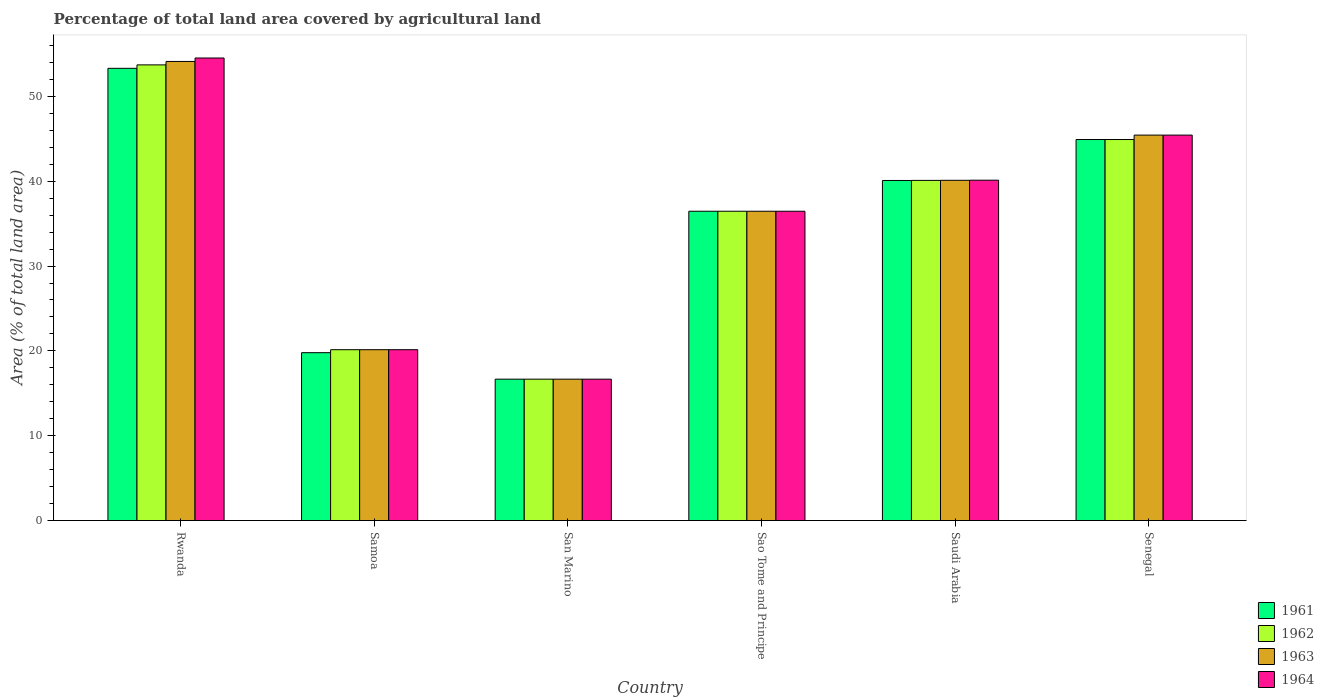How many different coloured bars are there?
Your answer should be very brief. 4. How many bars are there on the 3rd tick from the left?
Ensure brevity in your answer.  4. How many bars are there on the 3rd tick from the right?
Your response must be concise. 4. What is the label of the 4th group of bars from the left?
Give a very brief answer. Sao Tome and Principe. In how many cases, is the number of bars for a given country not equal to the number of legend labels?
Your answer should be compact. 0. What is the percentage of agricultural land in 1961 in Sao Tome and Principe?
Make the answer very short. 36.46. Across all countries, what is the maximum percentage of agricultural land in 1962?
Offer a very short reply. 53.71. Across all countries, what is the minimum percentage of agricultural land in 1963?
Provide a short and direct response. 16.67. In which country was the percentage of agricultural land in 1962 maximum?
Make the answer very short. Rwanda. In which country was the percentage of agricultural land in 1963 minimum?
Provide a succinct answer. San Marino. What is the total percentage of agricultural land in 1964 in the graph?
Your answer should be very brief. 213.34. What is the difference between the percentage of agricultural land in 1961 in Saudi Arabia and that in Senegal?
Your response must be concise. -4.83. What is the difference between the percentage of agricultural land in 1961 in San Marino and the percentage of agricultural land in 1962 in Senegal?
Keep it short and to the point. -28.25. What is the average percentage of agricultural land in 1962 per country?
Give a very brief answer. 35.33. What is the ratio of the percentage of agricultural land in 1962 in Sao Tome and Principe to that in Saudi Arabia?
Provide a succinct answer. 0.91. What is the difference between the highest and the second highest percentage of agricultural land in 1961?
Ensure brevity in your answer.  -4.83. What is the difference between the highest and the lowest percentage of agricultural land in 1962?
Your answer should be very brief. 37.04. Is the sum of the percentage of agricultural land in 1961 in Samoa and Sao Tome and Principe greater than the maximum percentage of agricultural land in 1963 across all countries?
Your answer should be compact. Yes. Is it the case that in every country, the sum of the percentage of agricultural land in 1962 and percentage of agricultural land in 1964 is greater than the sum of percentage of agricultural land in 1963 and percentage of agricultural land in 1961?
Your response must be concise. No. What does the 4th bar from the left in Sao Tome and Principe represents?
Provide a short and direct response. 1964. Are all the bars in the graph horizontal?
Keep it short and to the point. No. How many countries are there in the graph?
Keep it short and to the point. 6. What is the difference between two consecutive major ticks on the Y-axis?
Offer a very short reply. 10. Are the values on the major ticks of Y-axis written in scientific E-notation?
Offer a terse response. No. Does the graph contain grids?
Ensure brevity in your answer.  No. Where does the legend appear in the graph?
Give a very brief answer. Bottom right. How are the legend labels stacked?
Your response must be concise. Vertical. What is the title of the graph?
Your response must be concise. Percentage of total land area covered by agricultural land. Does "1968" appear as one of the legend labels in the graph?
Keep it short and to the point. No. What is the label or title of the X-axis?
Keep it short and to the point. Country. What is the label or title of the Y-axis?
Offer a very short reply. Area (% of total land area). What is the Area (% of total land area) of 1961 in Rwanda?
Your response must be concise. 53.3. What is the Area (% of total land area) of 1962 in Rwanda?
Offer a very short reply. 53.71. What is the Area (% of total land area) of 1963 in Rwanda?
Provide a succinct answer. 54.11. What is the Area (% of total land area) of 1964 in Rwanda?
Your answer should be very brief. 54.52. What is the Area (% of total land area) in 1961 in Samoa?
Your answer should be compact. 19.79. What is the Area (% of total land area) of 1962 in Samoa?
Provide a succinct answer. 20.14. What is the Area (% of total land area) in 1963 in Samoa?
Your response must be concise. 20.14. What is the Area (% of total land area) in 1964 in Samoa?
Provide a short and direct response. 20.14. What is the Area (% of total land area) of 1961 in San Marino?
Give a very brief answer. 16.67. What is the Area (% of total land area) in 1962 in San Marino?
Keep it short and to the point. 16.67. What is the Area (% of total land area) in 1963 in San Marino?
Give a very brief answer. 16.67. What is the Area (% of total land area) in 1964 in San Marino?
Keep it short and to the point. 16.67. What is the Area (% of total land area) in 1961 in Sao Tome and Principe?
Offer a very short reply. 36.46. What is the Area (% of total land area) in 1962 in Sao Tome and Principe?
Give a very brief answer. 36.46. What is the Area (% of total land area) of 1963 in Sao Tome and Principe?
Give a very brief answer. 36.46. What is the Area (% of total land area) in 1964 in Sao Tome and Principe?
Make the answer very short. 36.46. What is the Area (% of total land area) of 1961 in Saudi Arabia?
Ensure brevity in your answer.  40.08. What is the Area (% of total land area) of 1962 in Saudi Arabia?
Make the answer very short. 40.09. What is the Area (% of total land area) of 1963 in Saudi Arabia?
Make the answer very short. 40.1. What is the Area (% of total land area) of 1964 in Saudi Arabia?
Offer a terse response. 40.12. What is the Area (% of total land area) in 1961 in Senegal?
Make the answer very short. 44.91. What is the Area (% of total land area) in 1962 in Senegal?
Offer a terse response. 44.91. What is the Area (% of total land area) in 1963 in Senegal?
Your answer should be compact. 45.43. What is the Area (% of total land area) of 1964 in Senegal?
Your response must be concise. 45.43. Across all countries, what is the maximum Area (% of total land area) in 1961?
Provide a succinct answer. 53.3. Across all countries, what is the maximum Area (% of total land area) in 1962?
Your answer should be compact. 53.71. Across all countries, what is the maximum Area (% of total land area) in 1963?
Give a very brief answer. 54.11. Across all countries, what is the maximum Area (% of total land area) of 1964?
Make the answer very short. 54.52. Across all countries, what is the minimum Area (% of total land area) in 1961?
Offer a terse response. 16.67. Across all countries, what is the minimum Area (% of total land area) in 1962?
Keep it short and to the point. 16.67. Across all countries, what is the minimum Area (% of total land area) of 1963?
Provide a succinct answer. 16.67. Across all countries, what is the minimum Area (% of total land area) in 1964?
Ensure brevity in your answer.  16.67. What is the total Area (% of total land area) of 1961 in the graph?
Your answer should be very brief. 211.21. What is the total Area (% of total land area) in 1962 in the graph?
Make the answer very short. 211.98. What is the total Area (% of total land area) of 1963 in the graph?
Provide a succinct answer. 212.92. What is the total Area (% of total land area) of 1964 in the graph?
Provide a short and direct response. 213.34. What is the difference between the Area (% of total land area) in 1961 in Rwanda and that in Samoa?
Your answer should be compact. 33.52. What is the difference between the Area (% of total land area) in 1962 in Rwanda and that in Samoa?
Keep it short and to the point. 33.57. What is the difference between the Area (% of total land area) of 1963 in Rwanda and that in Samoa?
Your answer should be compact. 33.97. What is the difference between the Area (% of total land area) in 1964 in Rwanda and that in Samoa?
Provide a short and direct response. 34.38. What is the difference between the Area (% of total land area) in 1961 in Rwanda and that in San Marino?
Ensure brevity in your answer.  36.64. What is the difference between the Area (% of total land area) in 1962 in Rwanda and that in San Marino?
Your answer should be compact. 37.04. What is the difference between the Area (% of total land area) of 1963 in Rwanda and that in San Marino?
Give a very brief answer. 37.45. What is the difference between the Area (% of total land area) in 1964 in Rwanda and that in San Marino?
Provide a short and direct response. 37.85. What is the difference between the Area (% of total land area) in 1961 in Rwanda and that in Sao Tome and Principe?
Offer a terse response. 16.85. What is the difference between the Area (% of total land area) in 1962 in Rwanda and that in Sao Tome and Principe?
Your answer should be very brief. 17.25. What is the difference between the Area (% of total land area) in 1963 in Rwanda and that in Sao Tome and Principe?
Keep it short and to the point. 17.66. What is the difference between the Area (% of total land area) of 1964 in Rwanda and that in Sao Tome and Principe?
Offer a terse response. 18.06. What is the difference between the Area (% of total land area) in 1961 in Rwanda and that in Saudi Arabia?
Your answer should be very brief. 13.22. What is the difference between the Area (% of total land area) of 1962 in Rwanda and that in Saudi Arabia?
Your answer should be compact. 13.61. What is the difference between the Area (% of total land area) of 1963 in Rwanda and that in Saudi Arabia?
Your answer should be compact. 14.01. What is the difference between the Area (% of total land area) in 1964 in Rwanda and that in Saudi Arabia?
Give a very brief answer. 14.4. What is the difference between the Area (% of total land area) of 1961 in Rwanda and that in Senegal?
Keep it short and to the point. 8.39. What is the difference between the Area (% of total land area) in 1962 in Rwanda and that in Senegal?
Offer a terse response. 8.8. What is the difference between the Area (% of total land area) of 1963 in Rwanda and that in Senegal?
Give a very brief answer. 8.68. What is the difference between the Area (% of total land area) of 1964 in Rwanda and that in Senegal?
Provide a succinct answer. 9.09. What is the difference between the Area (% of total land area) in 1961 in Samoa and that in San Marino?
Ensure brevity in your answer.  3.12. What is the difference between the Area (% of total land area) in 1962 in Samoa and that in San Marino?
Your answer should be compact. 3.47. What is the difference between the Area (% of total land area) in 1963 in Samoa and that in San Marino?
Provide a succinct answer. 3.47. What is the difference between the Area (% of total land area) of 1964 in Samoa and that in San Marino?
Your response must be concise. 3.47. What is the difference between the Area (% of total land area) of 1961 in Samoa and that in Sao Tome and Principe?
Your answer should be compact. -16.67. What is the difference between the Area (% of total land area) of 1962 in Samoa and that in Sao Tome and Principe?
Your answer should be compact. -16.32. What is the difference between the Area (% of total land area) of 1963 in Samoa and that in Sao Tome and Principe?
Your response must be concise. -16.32. What is the difference between the Area (% of total land area) of 1964 in Samoa and that in Sao Tome and Principe?
Ensure brevity in your answer.  -16.32. What is the difference between the Area (% of total land area) in 1961 in Samoa and that in Saudi Arabia?
Keep it short and to the point. -20.3. What is the difference between the Area (% of total land area) in 1962 in Samoa and that in Saudi Arabia?
Keep it short and to the point. -19.95. What is the difference between the Area (% of total land area) of 1963 in Samoa and that in Saudi Arabia?
Keep it short and to the point. -19.96. What is the difference between the Area (% of total land area) of 1964 in Samoa and that in Saudi Arabia?
Your answer should be very brief. -19.98. What is the difference between the Area (% of total land area) of 1961 in Samoa and that in Senegal?
Ensure brevity in your answer.  -25.12. What is the difference between the Area (% of total land area) of 1962 in Samoa and that in Senegal?
Your answer should be very brief. -24.77. What is the difference between the Area (% of total land area) in 1963 in Samoa and that in Senegal?
Provide a short and direct response. -25.29. What is the difference between the Area (% of total land area) in 1964 in Samoa and that in Senegal?
Offer a terse response. -25.29. What is the difference between the Area (% of total land area) of 1961 in San Marino and that in Sao Tome and Principe?
Your answer should be compact. -19.79. What is the difference between the Area (% of total land area) in 1962 in San Marino and that in Sao Tome and Principe?
Keep it short and to the point. -19.79. What is the difference between the Area (% of total land area) of 1963 in San Marino and that in Sao Tome and Principe?
Your answer should be compact. -19.79. What is the difference between the Area (% of total land area) in 1964 in San Marino and that in Sao Tome and Principe?
Your response must be concise. -19.79. What is the difference between the Area (% of total land area) of 1961 in San Marino and that in Saudi Arabia?
Your response must be concise. -23.42. What is the difference between the Area (% of total land area) in 1962 in San Marino and that in Saudi Arabia?
Your response must be concise. -23.43. What is the difference between the Area (% of total land area) of 1963 in San Marino and that in Saudi Arabia?
Your answer should be very brief. -23.44. What is the difference between the Area (% of total land area) of 1964 in San Marino and that in Saudi Arabia?
Give a very brief answer. -23.45. What is the difference between the Area (% of total land area) in 1961 in San Marino and that in Senegal?
Provide a succinct answer. -28.25. What is the difference between the Area (% of total land area) in 1962 in San Marino and that in Senegal?
Offer a terse response. -28.25. What is the difference between the Area (% of total land area) of 1963 in San Marino and that in Senegal?
Provide a short and direct response. -28.77. What is the difference between the Area (% of total land area) in 1964 in San Marino and that in Senegal?
Provide a succinct answer. -28.77. What is the difference between the Area (% of total land area) in 1961 in Sao Tome and Principe and that in Saudi Arabia?
Ensure brevity in your answer.  -3.63. What is the difference between the Area (% of total land area) of 1962 in Sao Tome and Principe and that in Saudi Arabia?
Your answer should be compact. -3.64. What is the difference between the Area (% of total land area) in 1963 in Sao Tome and Principe and that in Saudi Arabia?
Provide a short and direct response. -3.65. What is the difference between the Area (% of total land area) in 1964 in Sao Tome and Principe and that in Saudi Arabia?
Provide a short and direct response. -3.66. What is the difference between the Area (% of total land area) in 1961 in Sao Tome and Principe and that in Senegal?
Ensure brevity in your answer.  -8.45. What is the difference between the Area (% of total land area) of 1962 in Sao Tome and Principe and that in Senegal?
Offer a terse response. -8.45. What is the difference between the Area (% of total land area) in 1963 in Sao Tome and Principe and that in Senegal?
Provide a succinct answer. -8.97. What is the difference between the Area (% of total land area) in 1964 in Sao Tome and Principe and that in Senegal?
Make the answer very short. -8.97. What is the difference between the Area (% of total land area) in 1961 in Saudi Arabia and that in Senegal?
Provide a succinct answer. -4.83. What is the difference between the Area (% of total land area) in 1962 in Saudi Arabia and that in Senegal?
Make the answer very short. -4.82. What is the difference between the Area (% of total land area) in 1963 in Saudi Arabia and that in Senegal?
Ensure brevity in your answer.  -5.33. What is the difference between the Area (% of total land area) in 1964 in Saudi Arabia and that in Senegal?
Your response must be concise. -5.31. What is the difference between the Area (% of total land area) of 1961 in Rwanda and the Area (% of total land area) of 1962 in Samoa?
Offer a terse response. 33.16. What is the difference between the Area (% of total land area) of 1961 in Rwanda and the Area (% of total land area) of 1963 in Samoa?
Keep it short and to the point. 33.16. What is the difference between the Area (% of total land area) of 1961 in Rwanda and the Area (% of total land area) of 1964 in Samoa?
Your response must be concise. 33.16. What is the difference between the Area (% of total land area) of 1962 in Rwanda and the Area (% of total land area) of 1963 in Samoa?
Ensure brevity in your answer.  33.57. What is the difference between the Area (% of total land area) of 1962 in Rwanda and the Area (% of total land area) of 1964 in Samoa?
Provide a short and direct response. 33.57. What is the difference between the Area (% of total land area) of 1963 in Rwanda and the Area (% of total land area) of 1964 in Samoa?
Provide a short and direct response. 33.97. What is the difference between the Area (% of total land area) in 1961 in Rwanda and the Area (% of total land area) in 1962 in San Marino?
Your response must be concise. 36.64. What is the difference between the Area (% of total land area) of 1961 in Rwanda and the Area (% of total land area) of 1963 in San Marino?
Your answer should be very brief. 36.64. What is the difference between the Area (% of total land area) of 1961 in Rwanda and the Area (% of total land area) of 1964 in San Marino?
Give a very brief answer. 36.64. What is the difference between the Area (% of total land area) of 1962 in Rwanda and the Area (% of total land area) of 1963 in San Marino?
Your answer should be very brief. 37.04. What is the difference between the Area (% of total land area) in 1962 in Rwanda and the Area (% of total land area) in 1964 in San Marino?
Give a very brief answer. 37.04. What is the difference between the Area (% of total land area) in 1963 in Rwanda and the Area (% of total land area) in 1964 in San Marino?
Keep it short and to the point. 37.45. What is the difference between the Area (% of total land area) in 1961 in Rwanda and the Area (% of total land area) in 1962 in Sao Tome and Principe?
Give a very brief answer. 16.85. What is the difference between the Area (% of total land area) of 1961 in Rwanda and the Area (% of total land area) of 1963 in Sao Tome and Principe?
Provide a short and direct response. 16.85. What is the difference between the Area (% of total land area) of 1961 in Rwanda and the Area (% of total land area) of 1964 in Sao Tome and Principe?
Your answer should be very brief. 16.85. What is the difference between the Area (% of total land area) in 1962 in Rwanda and the Area (% of total land area) in 1963 in Sao Tome and Principe?
Make the answer very short. 17.25. What is the difference between the Area (% of total land area) in 1962 in Rwanda and the Area (% of total land area) in 1964 in Sao Tome and Principe?
Keep it short and to the point. 17.25. What is the difference between the Area (% of total land area) in 1963 in Rwanda and the Area (% of total land area) in 1964 in Sao Tome and Principe?
Your response must be concise. 17.66. What is the difference between the Area (% of total land area) of 1961 in Rwanda and the Area (% of total land area) of 1962 in Saudi Arabia?
Provide a short and direct response. 13.21. What is the difference between the Area (% of total land area) in 1961 in Rwanda and the Area (% of total land area) in 1963 in Saudi Arabia?
Keep it short and to the point. 13.2. What is the difference between the Area (% of total land area) of 1961 in Rwanda and the Area (% of total land area) of 1964 in Saudi Arabia?
Ensure brevity in your answer.  13.19. What is the difference between the Area (% of total land area) of 1962 in Rwanda and the Area (% of total land area) of 1963 in Saudi Arabia?
Keep it short and to the point. 13.6. What is the difference between the Area (% of total land area) in 1962 in Rwanda and the Area (% of total land area) in 1964 in Saudi Arabia?
Provide a succinct answer. 13.59. What is the difference between the Area (% of total land area) in 1963 in Rwanda and the Area (% of total land area) in 1964 in Saudi Arabia?
Make the answer very short. 14. What is the difference between the Area (% of total land area) in 1961 in Rwanda and the Area (% of total land area) in 1962 in Senegal?
Make the answer very short. 8.39. What is the difference between the Area (% of total land area) of 1961 in Rwanda and the Area (% of total land area) of 1963 in Senegal?
Your answer should be compact. 7.87. What is the difference between the Area (% of total land area) of 1961 in Rwanda and the Area (% of total land area) of 1964 in Senegal?
Provide a succinct answer. 7.87. What is the difference between the Area (% of total land area) of 1962 in Rwanda and the Area (% of total land area) of 1963 in Senegal?
Your response must be concise. 8.28. What is the difference between the Area (% of total land area) in 1962 in Rwanda and the Area (% of total land area) in 1964 in Senegal?
Make the answer very short. 8.28. What is the difference between the Area (% of total land area) of 1963 in Rwanda and the Area (% of total land area) of 1964 in Senegal?
Your answer should be compact. 8.68. What is the difference between the Area (% of total land area) in 1961 in Samoa and the Area (% of total land area) in 1962 in San Marino?
Your answer should be very brief. 3.12. What is the difference between the Area (% of total land area) of 1961 in Samoa and the Area (% of total land area) of 1963 in San Marino?
Keep it short and to the point. 3.12. What is the difference between the Area (% of total land area) of 1961 in Samoa and the Area (% of total land area) of 1964 in San Marino?
Your answer should be very brief. 3.12. What is the difference between the Area (% of total land area) of 1962 in Samoa and the Area (% of total land area) of 1963 in San Marino?
Offer a very short reply. 3.47. What is the difference between the Area (% of total land area) of 1962 in Samoa and the Area (% of total land area) of 1964 in San Marino?
Provide a short and direct response. 3.47. What is the difference between the Area (% of total land area) in 1963 in Samoa and the Area (% of total land area) in 1964 in San Marino?
Provide a succinct answer. 3.47. What is the difference between the Area (% of total land area) of 1961 in Samoa and the Area (% of total land area) of 1962 in Sao Tome and Principe?
Your answer should be very brief. -16.67. What is the difference between the Area (% of total land area) of 1961 in Samoa and the Area (% of total land area) of 1963 in Sao Tome and Principe?
Offer a very short reply. -16.67. What is the difference between the Area (% of total land area) in 1961 in Samoa and the Area (% of total land area) in 1964 in Sao Tome and Principe?
Provide a short and direct response. -16.67. What is the difference between the Area (% of total land area) in 1962 in Samoa and the Area (% of total land area) in 1963 in Sao Tome and Principe?
Provide a succinct answer. -16.32. What is the difference between the Area (% of total land area) of 1962 in Samoa and the Area (% of total land area) of 1964 in Sao Tome and Principe?
Provide a succinct answer. -16.32. What is the difference between the Area (% of total land area) in 1963 in Samoa and the Area (% of total land area) in 1964 in Sao Tome and Principe?
Provide a short and direct response. -16.32. What is the difference between the Area (% of total land area) of 1961 in Samoa and the Area (% of total land area) of 1962 in Saudi Arabia?
Your answer should be very brief. -20.31. What is the difference between the Area (% of total land area) in 1961 in Samoa and the Area (% of total land area) in 1963 in Saudi Arabia?
Your answer should be very brief. -20.32. What is the difference between the Area (% of total land area) in 1961 in Samoa and the Area (% of total land area) in 1964 in Saudi Arabia?
Make the answer very short. -20.33. What is the difference between the Area (% of total land area) in 1962 in Samoa and the Area (% of total land area) in 1963 in Saudi Arabia?
Provide a short and direct response. -19.96. What is the difference between the Area (% of total land area) of 1962 in Samoa and the Area (% of total land area) of 1964 in Saudi Arabia?
Offer a very short reply. -19.98. What is the difference between the Area (% of total land area) in 1963 in Samoa and the Area (% of total land area) in 1964 in Saudi Arabia?
Ensure brevity in your answer.  -19.98. What is the difference between the Area (% of total land area) of 1961 in Samoa and the Area (% of total land area) of 1962 in Senegal?
Give a very brief answer. -25.12. What is the difference between the Area (% of total land area) in 1961 in Samoa and the Area (% of total land area) in 1963 in Senegal?
Your answer should be compact. -25.64. What is the difference between the Area (% of total land area) in 1961 in Samoa and the Area (% of total land area) in 1964 in Senegal?
Offer a very short reply. -25.64. What is the difference between the Area (% of total land area) of 1962 in Samoa and the Area (% of total land area) of 1963 in Senegal?
Your answer should be very brief. -25.29. What is the difference between the Area (% of total land area) in 1962 in Samoa and the Area (% of total land area) in 1964 in Senegal?
Keep it short and to the point. -25.29. What is the difference between the Area (% of total land area) of 1963 in Samoa and the Area (% of total land area) of 1964 in Senegal?
Provide a succinct answer. -25.29. What is the difference between the Area (% of total land area) of 1961 in San Marino and the Area (% of total land area) of 1962 in Sao Tome and Principe?
Offer a terse response. -19.79. What is the difference between the Area (% of total land area) in 1961 in San Marino and the Area (% of total land area) in 1963 in Sao Tome and Principe?
Your answer should be very brief. -19.79. What is the difference between the Area (% of total land area) in 1961 in San Marino and the Area (% of total land area) in 1964 in Sao Tome and Principe?
Give a very brief answer. -19.79. What is the difference between the Area (% of total land area) in 1962 in San Marino and the Area (% of total land area) in 1963 in Sao Tome and Principe?
Your answer should be very brief. -19.79. What is the difference between the Area (% of total land area) of 1962 in San Marino and the Area (% of total land area) of 1964 in Sao Tome and Principe?
Your answer should be very brief. -19.79. What is the difference between the Area (% of total land area) of 1963 in San Marino and the Area (% of total land area) of 1964 in Sao Tome and Principe?
Give a very brief answer. -19.79. What is the difference between the Area (% of total land area) of 1961 in San Marino and the Area (% of total land area) of 1962 in Saudi Arabia?
Offer a very short reply. -23.43. What is the difference between the Area (% of total land area) in 1961 in San Marino and the Area (% of total land area) in 1963 in Saudi Arabia?
Provide a succinct answer. -23.44. What is the difference between the Area (% of total land area) of 1961 in San Marino and the Area (% of total land area) of 1964 in Saudi Arabia?
Give a very brief answer. -23.45. What is the difference between the Area (% of total land area) of 1962 in San Marino and the Area (% of total land area) of 1963 in Saudi Arabia?
Offer a terse response. -23.44. What is the difference between the Area (% of total land area) in 1962 in San Marino and the Area (% of total land area) in 1964 in Saudi Arabia?
Your response must be concise. -23.45. What is the difference between the Area (% of total land area) in 1963 in San Marino and the Area (% of total land area) in 1964 in Saudi Arabia?
Your answer should be compact. -23.45. What is the difference between the Area (% of total land area) of 1961 in San Marino and the Area (% of total land area) of 1962 in Senegal?
Keep it short and to the point. -28.25. What is the difference between the Area (% of total land area) in 1961 in San Marino and the Area (% of total land area) in 1963 in Senegal?
Your response must be concise. -28.77. What is the difference between the Area (% of total land area) of 1961 in San Marino and the Area (% of total land area) of 1964 in Senegal?
Keep it short and to the point. -28.77. What is the difference between the Area (% of total land area) in 1962 in San Marino and the Area (% of total land area) in 1963 in Senegal?
Your response must be concise. -28.77. What is the difference between the Area (% of total land area) of 1962 in San Marino and the Area (% of total land area) of 1964 in Senegal?
Keep it short and to the point. -28.77. What is the difference between the Area (% of total land area) of 1963 in San Marino and the Area (% of total land area) of 1964 in Senegal?
Provide a succinct answer. -28.77. What is the difference between the Area (% of total land area) in 1961 in Sao Tome and Principe and the Area (% of total land area) in 1962 in Saudi Arabia?
Provide a succinct answer. -3.64. What is the difference between the Area (% of total land area) in 1961 in Sao Tome and Principe and the Area (% of total land area) in 1963 in Saudi Arabia?
Provide a succinct answer. -3.65. What is the difference between the Area (% of total land area) of 1961 in Sao Tome and Principe and the Area (% of total land area) of 1964 in Saudi Arabia?
Your response must be concise. -3.66. What is the difference between the Area (% of total land area) of 1962 in Sao Tome and Principe and the Area (% of total land area) of 1963 in Saudi Arabia?
Provide a succinct answer. -3.65. What is the difference between the Area (% of total land area) in 1962 in Sao Tome and Principe and the Area (% of total land area) in 1964 in Saudi Arabia?
Your response must be concise. -3.66. What is the difference between the Area (% of total land area) in 1963 in Sao Tome and Principe and the Area (% of total land area) in 1964 in Saudi Arabia?
Provide a succinct answer. -3.66. What is the difference between the Area (% of total land area) of 1961 in Sao Tome and Principe and the Area (% of total land area) of 1962 in Senegal?
Keep it short and to the point. -8.45. What is the difference between the Area (% of total land area) in 1961 in Sao Tome and Principe and the Area (% of total land area) in 1963 in Senegal?
Provide a short and direct response. -8.97. What is the difference between the Area (% of total land area) of 1961 in Sao Tome and Principe and the Area (% of total land area) of 1964 in Senegal?
Your response must be concise. -8.97. What is the difference between the Area (% of total land area) of 1962 in Sao Tome and Principe and the Area (% of total land area) of 1963 in Senegal?
Make the answer very short. -8.97. What is the difference between the Area (% of total land area) of 1962 in Sao Tome and Principe and the Area (% of total land area) of 1964 in Senegal?
Provide a short and direct response. -8.97. What is the difference between the Area (% of total land area) in 1963 in Sao Tome and Principe and the Area (% of total land area) in 1964 in Senegal?
Your response must be concise. -8.97. What is the difference between the Area (% of total land area) in 1961 in Saudi Arabia and the Area (% of total land area) in 1962 in Senegal?
Provide a succinct answer. -4.83. What is the difference between the Area (% of total land area) of 1961 in Saudi Arabia and the Area (% of total land area) of 1963 in Senegal?
Provide a short and direct response. -5.35. What is the difference between the Area (% of total land area) of 1961 in Saudi Arabia and the Area (% of total land area) of 1964 in Senegal?
Provide a short and direct response. -5.35. What is the difference between the Area (% of total land area) of 1962 in Saudi Arabia and the Area (% of total land area) of 1963 in Senegal?
Your response must be concise. -5.34. What is the difference between the Area (% of total land area) in 1962 in Saudi Arabia and the Area (% of total land area) in 1964 in Senegal?
Your answer should be compact. -5.34. What is the difference between the Area (% of total land area) of 1963 in Saudi Arabia and the Area (% of total land area) of 1964 in Senegal?
Give a very brief answer. -5.33. What is the average Area (% of total land area) in 1961 per country?
Your answer should be compact. 35.2. What is the average Area (% of total land area) in 1962 per country?
Give a very brief answer. 35.33. What is the average Area (% of total land area) in 1963 per country?
Your response must be concise. 35.49. What is the average Area (% of total land area) of 1964 per country?
Give a very brief answer. 35.56. What is the difference between the Area (% of total land area) in 1961 and Area (% of total land area) in 1962 in Rwanda?
Offer a terse response. -0.41. What is the difference between the Area (% of total land area) in 1961 and Area (% of total land area) in 1963 in Rwanda?
Provide a succinct answer. -0.81. What is the difference between the Area (% of total land area) in 1961 and Area (% of total land area) in 1964 in Rwanda?
Ensure brevity in your answer.  -1.22. What is the difference between the Area (% of total land area) in 1962 and Area (% of total land area) in 1963 in Rwanda?
Your answer should be compact. -0.41. What is the difference between the Area (% of total land area) in 1962 and Area (% of total land area) in 1964 in Rwanda?
Make the answer very short. -0.81. What is the difference between the Area (% of total land area) of 1963 and Area (% of total land area) of 1964 in Rwanda?
Offer a very short reply. -0.41. What is the difference between the Area (% of total land area) in 1961 and Area (% of total land area) in 1962 in Samoa?
Make the answer very short. -0.35. What is the difference between the Area (% of total land area) of 1961 and Area (% of total land area) of 1963 in Samoa?
Offer a terse response. -0.35. What is the difference between the Area (% of total land area) of 1961 and Area (% of total land area) of 1964 in Samoa?
Ensure brevity in your answer.  -0.35. What is the difference between the Area (% of total land area) of 1963 and Area (% of total land area) of 1964 in Samoa?
Your response must be concise. 0. What is the difference between the Area (% of total land area) in 1961 and Area (% of total land area) in 1962 in San Marino?
Your answer should be very brief. 0. What is the difference between the Area (% of total land area) in 1961 and Area (% of total land area) in 1963 in San Marino?
Keep it short and to the point. 0. What is the difference between the Area (% of total land area) in 1961 and Area (% of total land area) in 1964 in San Marino?
Provide a succinct answer. 0. What is the difference between the Area (% of total land area) in 1961 and Area (% of total land area) in 1963 in Sao Tome and Principe?
Keep it short and to the point. 0. What is the difference between the Area (% of total land area) of 1961 and Area (% of total land area) of 1964 in Sao Tome and Principe?
Keep it short and to the point. 0. What is the difference between the Area (% of total land area) of 1962 and Area (% of total land area) of 1963 in Sao Tome and Principe?
Your answer should be very brief. 0. What is the difference between the Area (% of total land area) of 1961 and Area (% of total land area) of 1962 in Saudi Arabia?
Provide a short and direct response. -0.01. What is the difference between the Area (% of total land area) of 1961 and Area (% of total land area) of 1963 in Saudi Arabia?
Your response must be concise. -0.02. What is the difference between the Area (% of total land area) of 1961 and Area (% of total land area) of 1964 in Saudi Arabia?
Ensure brevity in your answer.  -0.03. What is the difference between the Area (% of total land area) of 1962 and Area (% of total land area) of 1963 in Saudi Arabia?
Your response must be concise. -0.01. What is the difference between the Area (% of total land area) in 1962 and Area (% of total land area) in 1964 in Saudi Arabia?
Ensure brevity in your answer.  -0.02. What is the difference between the Area (% of total land area) of 1963 and Area (% of total land area) of 1964 in Saudi Arabia?
Your response must be concise. -0.01. What is the difference between the Area (% of total land area) in 1961 and Area (% of total land area) in 1963 in Senegal?
Make the answer very short. -0.52. What is the difference between the Area (% of total land area) of 1961 and Area (% of total land area) of 1964 in Senegal?
Ensure brevity in your answer.  -0.52. What is the difference between the Area (% of total land area) in 1962 and Area (% of total land area) in 1963 in Senegal?
Your answer should be compact. -0.52. What is the difference between the Area (% of total land area) of 1962 and Area (% of total land area) of 1964 in Senegal?
Ensure brevity in your answer.  -0.52. What is the difference between the Area (% of total land area) in 1963 and Area (% of total land area) in 1964 in Senegal?
Your answer should be very brief. 0. What is the ratio of the Area (% of total land area) of 1961 in Rwanda to that in Samoa?
Your answer should be compact. 2.69. What is the ratio of the Area (% of total land area) of 1962 in Rwanda to that in Samoa?
Your answer should be compact. 2.67. What is the ratio of the Area (% of total land area) in 1963 in Rwanda to that in Samoa?
Provide a succinct answer. 2.69. What is the ratio of the Area (% of total land area) in 1964 in Rwanda to that in Samoa?
Offer a very short reply. 2.71. What is the ratio of the Area (% of total land area) of 1961 in Rwanda to that in San Marino?
Your answer should be very brief. 3.2. What is the ratio of the Area (% of total land area) in 1962 in Rwanda to that in San Marino?
Your answer should be compact. 3.22. What is the ratio of the Area (% of total land area) in 1963 in Rwanda to that in San Marino?
Provide a succinct answer. 3.25. What is the ratio of the Area (% of total land area) in 1964 in Rwanda to that in San Marino?
Provide a short and direct response. 3.27. What is the ratio of the Area (% of total land area) in 1961 in Rwanda to that in Sao Tome and Principe?
Offer a very short reply. 1.46. What is the ratio of the Area (% of total land area) of 1962 in Rwanda to that in Sao Tome and Principe?
Your response must be concise. 1.47. What is the ratio of the Area (% of total land area) in 1963 in Rwanda to that in Sao Tome and Principe?
Your answer should be compact. 1.48. What is the ratio of the Area (% of total land area) of 1964 in Rwanda to that in Sao Tome and Principe?
Provide a succinct answer. 1.5. What is the ratio of the Area (% of total land area) of 1961 in Rwanda to that in Saudi Arabia?
Offer a very short reply. 1.33. What is the ratio of the Area (% of total land area) in 1962 in Rwanda to that in Saudi Arabia?
Keep it short and to the point. 1.34. What is the ratio of the Area (% of total land area) in 1963 in Rwanda to that in Saudi Arabia?
Provide a short and direct response. 1.35. What is the ratio of the Area (% of total land area) in 1964 in Rwanda to that in Saudi Arabia?
Give a very brief answer. 1.36. What is the ratio of the Area (% of total land area) in 1961 in Rwanda to that in Senegal?
Your response must be concise. 1.19. What is the ratio of the Area (% of total land area) in 1962 in Rwanda to that in Senegal?
Your answer should be compact. 1.2. What is the ratio of the Area (% of total land area) of 1963 in Rwanda to that in Senegal?
Keep it short and to the point. 1.19. What is the ratio of the Area (% of total land area) in 1964 in Rwanda to that in Senegal?
Make the answer very short. 1.2. What is the ratio of the Area (% of total land area) in 1961 in Samoa to that in San Marino?
Give a very brief answer. 1.19. What is the ratio of the Area (% of total land area) of 1962 in Samoa to that in San Marino?
Give a very brief answer. 1.21. What is the ratio of the Area (% of total land area) of 1963 in Samoa to that in San Marino?
Provide a succinct answer. 1.21. What is the ratio of the Area (% of total land area) in 1964 in Samoa to that in San Marino?
Ensure brevity in your answer.  1.21. What is the ratio of the Area (% of total land area) of 1961 in Samoa to that in Sao Tome and Principe?
Your answer should be very brief. 0.54. What is the ratio of the Area (% of total land area) in 1962 in Samoa to that in Sao Tome and Principe?
Give a very brief answer. 0.55. What is the ratio of the Area (% of total land area) in 1963 in Samoa to that in Sao Tome and Principe?
Provide a succinct answer. 0.55. What is the ratio of the Area (% of total land area) in 1964 in Samoa to that in Sao Tome and Principe?
Your answer should be very brief. 0.55. What is the ratio of the Area (% of total land area) in 1961 in Samoa to that in Saudi Arabia?
Your response must be concise. 0.49. What is the ratio of the Area (% of total land area) of 1962 in Samoa to that in Saudi Arabia?
Ensure brevity in your answer.  0.5. What is the ratio of the Area (% of total land area) in 1963 in Samoa to that in Saudi Arabia?
Keep it short and to the point. 0.5. What is the ratio of the Area (% of total land area) of 1964 in Samoa to that in Saudi Arabia?
Keep it short and to the point. 0.5. What is the ratio of the Area (% of total land area) in 1961 in Samoa to that in Senegal?
Your answer should be very brief. 0.44. What is the ratio of the Area (% of total land area) of 1962 in Samoa to that in Senegal?
Offer a very short reply. 0.45. What is the ratio of the Area (% of total land area) of 1963 in Samoa to that in Senegal?
Offer a very short reply. 0.44. What is the ratio of the Area (% of total land area) of 1964 in Samoa to that in Senegal?
Your answer should be compact. 0.44. What is the ratio of the Area (% of total land area) of 1961 in San Marino to that in Sao Tome and Principe?
Offer a very short reply. 0.46. What is the ratio of the Area (% of total land area) of 1962 in San Marino to that in Sao Tome and Principe?
Keep it short and to the point. 0.46. What is the ratio of the Area (% of total land area) in 1963 in San Marino to that in Sao Tome and Principe?
Give a very brief answer. 0.46. What is the ratio of the Area (% of total land area) of 1964 in San Marino to that in Sao Tome and Principe?
Your answer should be very brief. 0.46. What is the ratio of the Area (% of total land area) of 1961 in San Marino to that in Saudi Arabia?
Your response must be concise. 0.42. What is the ratio of the Area (% of total land area) in 1962 in San Marino to that in Saudi Arabia?
Your answer should be very brief. 0.42. What is the ratio of the Area (% of total land area) of 1963 in San Marino to that in Saudi Arabia?
Give a very brief answer. 0.42. What is the ratio of the Area (% of total land area) of 1964 in San Marino to that in Saudi Arabia?
Offer a very short reply. 0.42. What is the ratio of the Area (% of total land area) of 1961 in San Marino to that in Senegal?
Ensure brevity in your answer.  0.37. What is the ratio of the Area (% of total land area) in 1962 in San Marino to that in Senegal?
Provide a short and direct response. 0.37. What is the ratio of the Area (% of total land area) of 1963 in San Marino to that in Senegal?
Your response must be concise. 0.37. What is the ratio of the Area (% of total land area) of 1964 in San Marino to that in Senegal?
Your answer should be compact. 0.37. What is the ratio of the Area (% of total land area) in 1961 in Sao Tome and Principe to that in Saudi Arabia?
Your answer should be compact. 0.91. What is the ratio of the Area (% of total land area) of 1962 in Sao Tome and Principe to that in Saudi Arabia?
Offer a terse response. 0.91. What is the ratio of the Area (% of total land area) of 1964 in Sao Tome and Principe to that in Saudi Arabia?
Your answer should be compact. 0.91. What is the ratio of the Area (% of total land area) in 1961 in Sao Tome and Principe to that in Senegal?
Your answer should be very brief. 0.81. What is the ratio of the Area (% of total land area) in 1962 in Sao Tome and Principe to that in Senegal?
Your response must be concise. 0.81. What is the ratio of the Area (% of total land area) of 1963 in Sao Tome and Principe to that in Senegal?
Your response must be concise. 0.8. What is the ratio of the Area (% of total land area) in 1964 in Sao Tome and Principe to that in Senegal?
Offer a very short reply. 0.8. What is the ratio of the Area (% of total land area) in 1961 in Saudi Arabia to that in Senegal?
Your answer should be compact. 0.89. What is the ratio of the Area (% of total land area) of 1962 in Saudi Arabia to that in Senegal?
Ensure brevity in your answer.  0.89. What is the ratio of the Area (% of total land area) in 1963 in Saudi Arabia to that in Senegal?
Your response must be concise. 0.88. What is the ratio of the Area (% of total land area) in 1964 in Saudi Arabia to that in Senegal?
Offer a very short reply. 0.88. What is the difference between the highest and the second highest Area (% of total land area) of 1961?
Provide a succinct answer. 8.39. What is the difference between the highest and the second highest Area (% of total land area) of 1962?
Provide a short and direct response. 8.8. What is the difference between the highest and the second highest Area (% of total land area) in 1963?
Your answer should be compact. 8.68. What is the difference between the highest and the second highest Area (% of total land area) in 1964?
Offer a very short reply. 9.09. What is the difference between the highest and the lowest Area (% of total land area) of 1961?
Keep it short and to the point. 36.64. What is the difference between the highest and the lowest Area (% of total land area) of 1962?
Make the answer very short. 37.04. What is the difference between the highest and the lowest Area (% of total land area) in 1963?
Your answer should be compact. 37.45. What is the difference between the highest and the lowest Area (% of total land area) of 1964?
Offer a very short reply. 37.85. 